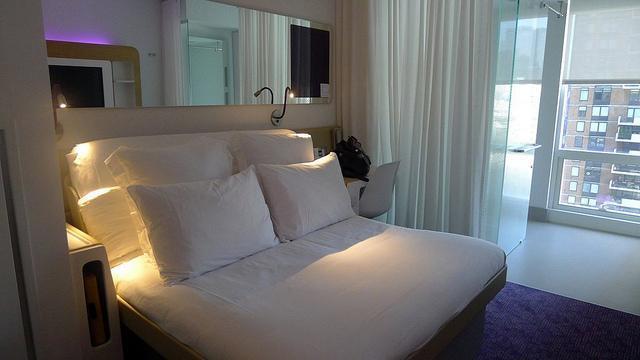How many pillows are on the bed?
Give a very brief answer. 4. How many people are wearing yellow shirt?
Give a very brief answer. 0. 